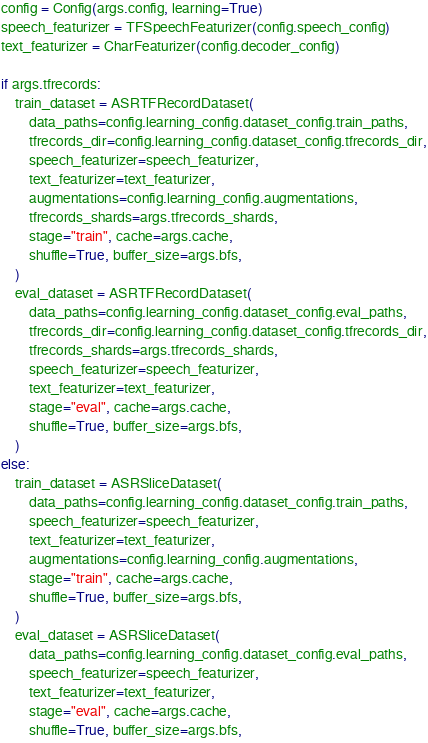<code> <loc_0><loc_0><loc_500><loc_500><_Python_>
config = Config(args.config, learning=True)
speech_featurizer = TFSpeechFeaturizer(config.speech_config)
text_featurizer = CharFeaturizer(config.decoder_config)

if args.tfrecords:
    train_dataset = ASRTFRecordDataset(
        data_paths=config.learning_config.dataset_config.train_paths,
        tfrecords_dir=config.learning_config.dataset_config.tfrecords_dir,
        speech_featurizer=speech_featurizer,
        text_featurizer=text_featurizer,
        augmentations=config.learning_config.augmentations,
        tfrecords_shards=args.tfrecords_shards,
        stage="train", cache=args.cache,
        shuffle=True, buffer_size=args.bfs,
    )
    eval_dataset = ASRTFRecordDataset(
        data_paths=config.learning_config.dataset_config.eval_paths,
        tfrecords_dir=config.learning_config.dataset_config.tfrecords_dir,
        tfrecords_shards=args.tfrecords_shards,
        speech_featurizer=speech_featurizer,
        text_featurizer=text_featurizer,
        stage="eval", cache=args.cache,
        shuffle=True, buffer_size=args.bfs,
    )
else:
    train_dataset = ASRSliceDataset(
        data_paths=config.learning_config.dataset_config.train_paths,
        speech_featurizer=speech_featurizer,
        text_featurizer=text_featurizer,
        augmentations=config.learning_config.augmentations,
        stage="train", cache=args.cache,
        shuffle=True, buffer_size=args.bfs,
    )
    eval_dataset = ASRSliceDataset(
        data_paths=config.learning_config.dataset_config.eval_paths,
        speech_featurizer=speech_featurizer,
        text_featurizer=text_featurizer,
        stage="eval", cache=args.cache,
        shuffle=True, buffer_size=args.bfs,</code> 